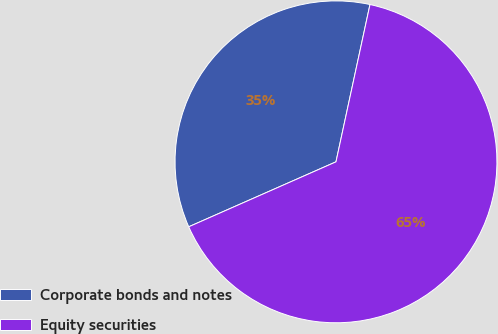<chart> <loc_0><loc_0><loc_500><loc_500><pie_chart><fcel>Corporate bonds and notes<fcel>Equity securities<nl><fcel>35.0%<fcel>65.0%<nl></chart> 